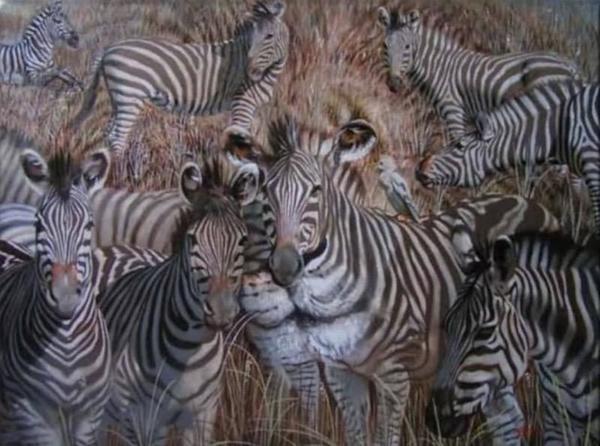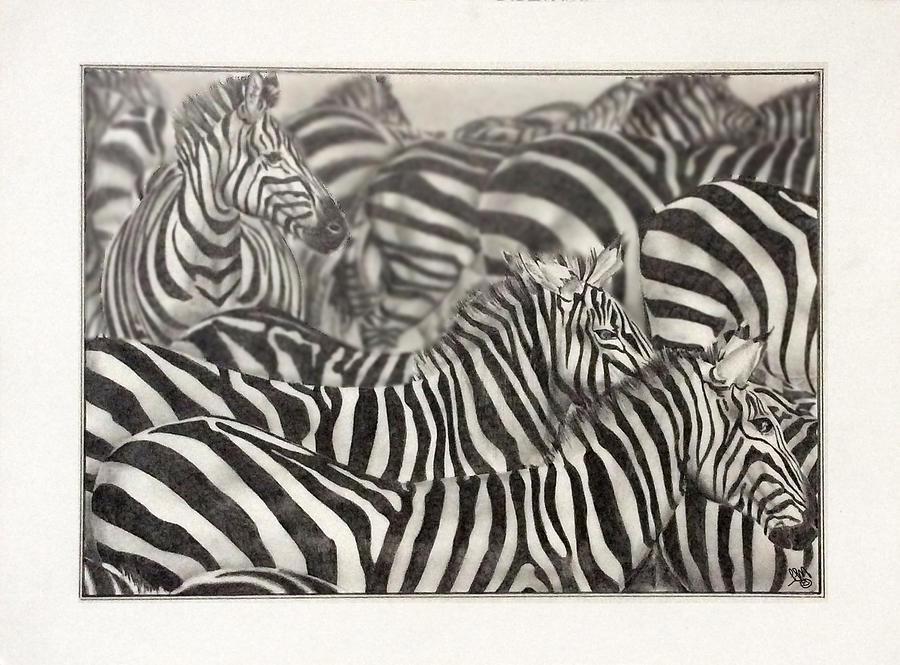The first image is the image on the left, the second image is the image on the right. For the images shown, is this caption "One image shows zebras in water and the other image shows zebras on grassland." true? Answer yes or no. No. The first image is the image on the left, the second image is the image on the right. Considering the images on both sides, is "One image shows multiple zebras standing in water up to their knees, and the other image shows multiple zebras standing on dry ground." valid? Answer yes or no. No. 